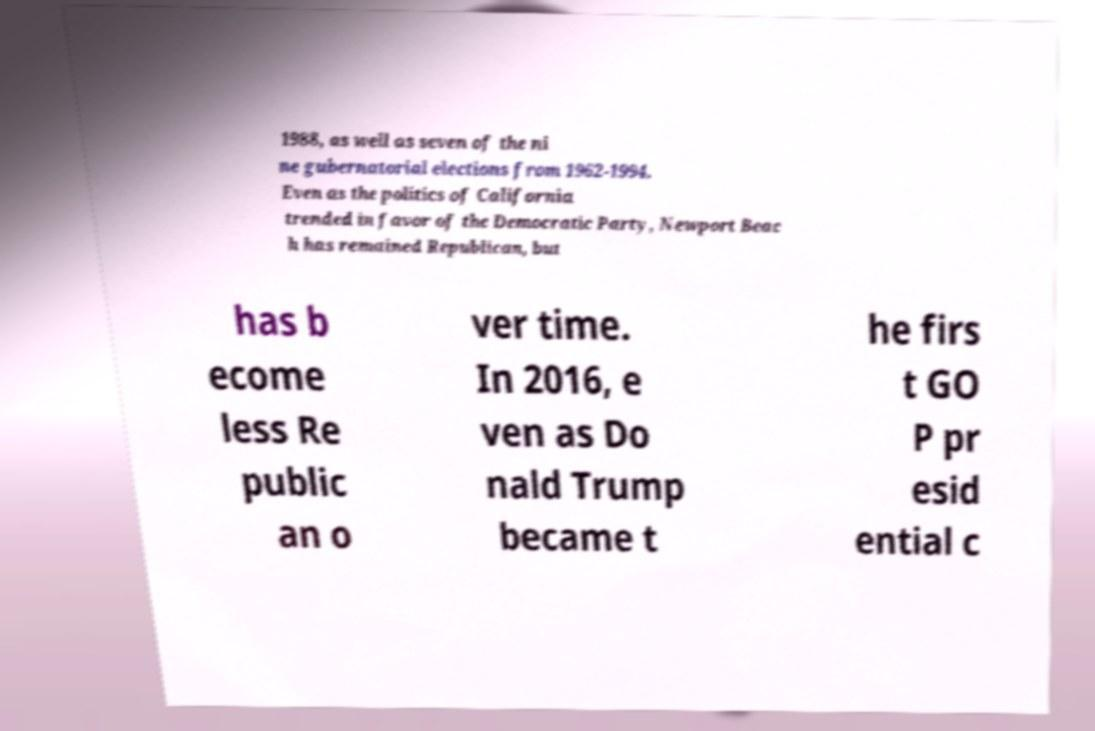For documentation purposes, I need the text within this image transcribed. Could you provide that? 1988, as well as seven of the ni ne gubernatorial elections from 1962-1994. Even as the politics of California trended in favor of the Democratic Party, Newport Beac h has remained Republican, but has b ecome less Re public an o ver time. In 2016, e ven as Do nald Trump became t he firs t GO P pr esid ential c 